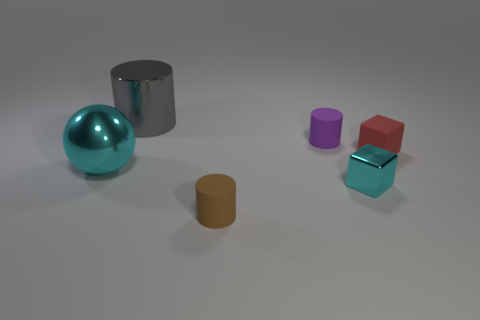Add 3 spheres. How many spheres are left? 4 Add 5 large metallic balls. How many large metallic balls exist? 6 Add 2 cyan blocks. How many objects exist? 8 Subtract all red cubes. How many cubes are left? 1 Subtract all matte cylinders. How many cylinders are left? 1 Subtract 0 yellow spheres. How many objects are left? 6 Subtract all blocks. How many objects are left? 4 Subtract 1 cylinders. How many cylinders are left? 2 Subtract all green cylinders. Subtract all blue balls. How many cylinders are left? 3 Subtract all cyan cylinders. How many purple cubes are left? 0 